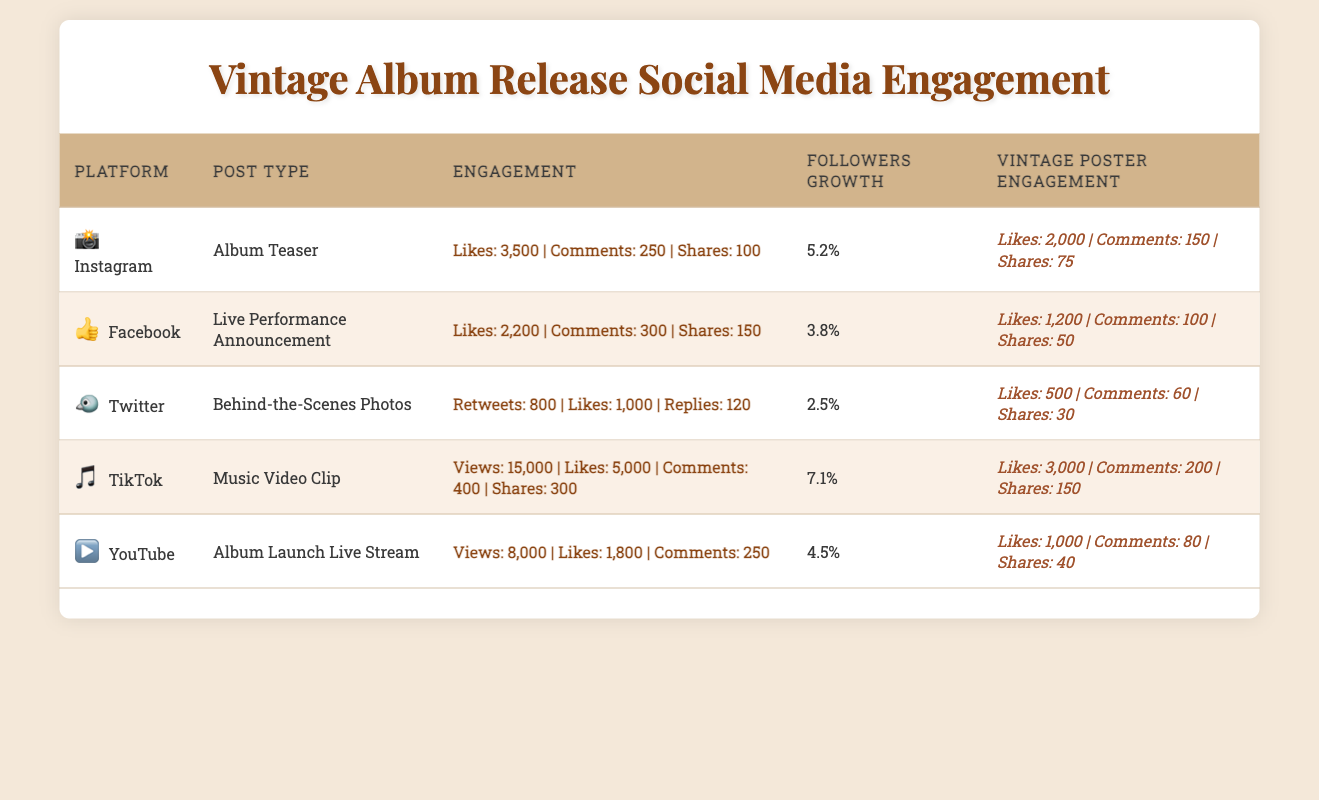What is the most engaged platform for vintage-style posters? To find the most engaged platform for vintage-style posters, we need to look at the likes, comments, and shares provided for the vintage poster engagement for each platform. By comparing: Instagram (Likes: 2000, Comments: 150, Shares: 75), Facebook (Likes: 1200, Comments: 100, Shares: 50), Twitter (Likes: 500, Comments: 60, Shares: 30), TikTok (Likes: 3000, Comments: 200, Shares: 150), and YouTube (Likes: 1000, Comments: 80, Shares: 40), TikTok has the highest likes at 3000 and is thus the most engaged platform.
Answer: TikTok How many total likes were received across all platforms for the album teaser and announcements? The relevant data includes Instagram (Likes: 3500), Facebook (Likes: 2200), and TikTok (Likes: 5000). The sum of these likes is 3500 + 2200 + 5000 = 10700.
Answer: 10700 Did the Facebook post receive more comments than the Twitter post? The Facebook post received 300 comments, while the Twitter post received 120 comments. Since 300 is greater than 120, the answer is yes.
Answer: Yes What is the total shares for all vintage-style poster engagements? To find the total shares, we sum the shares for each engagement: Instagram (Shares: 75), Facebook (Shares: 50), Twitter (Shares: 30), TikTok (Shares: 150), and YouTube (Shares: 40). The total is 75 + 50 + 30 + 150 + 40 = 345.
Answer: 345 What platform experienced the highest followers growth? Looking at the followers growth percentages, we have Instagram (5.2%), Facebook (3.8%), Twitter (2.5%), TikTok (7.1%), and YouTube (4.5%). TikTok has the highest percentage at 7.1%.
Answer: TikTok 